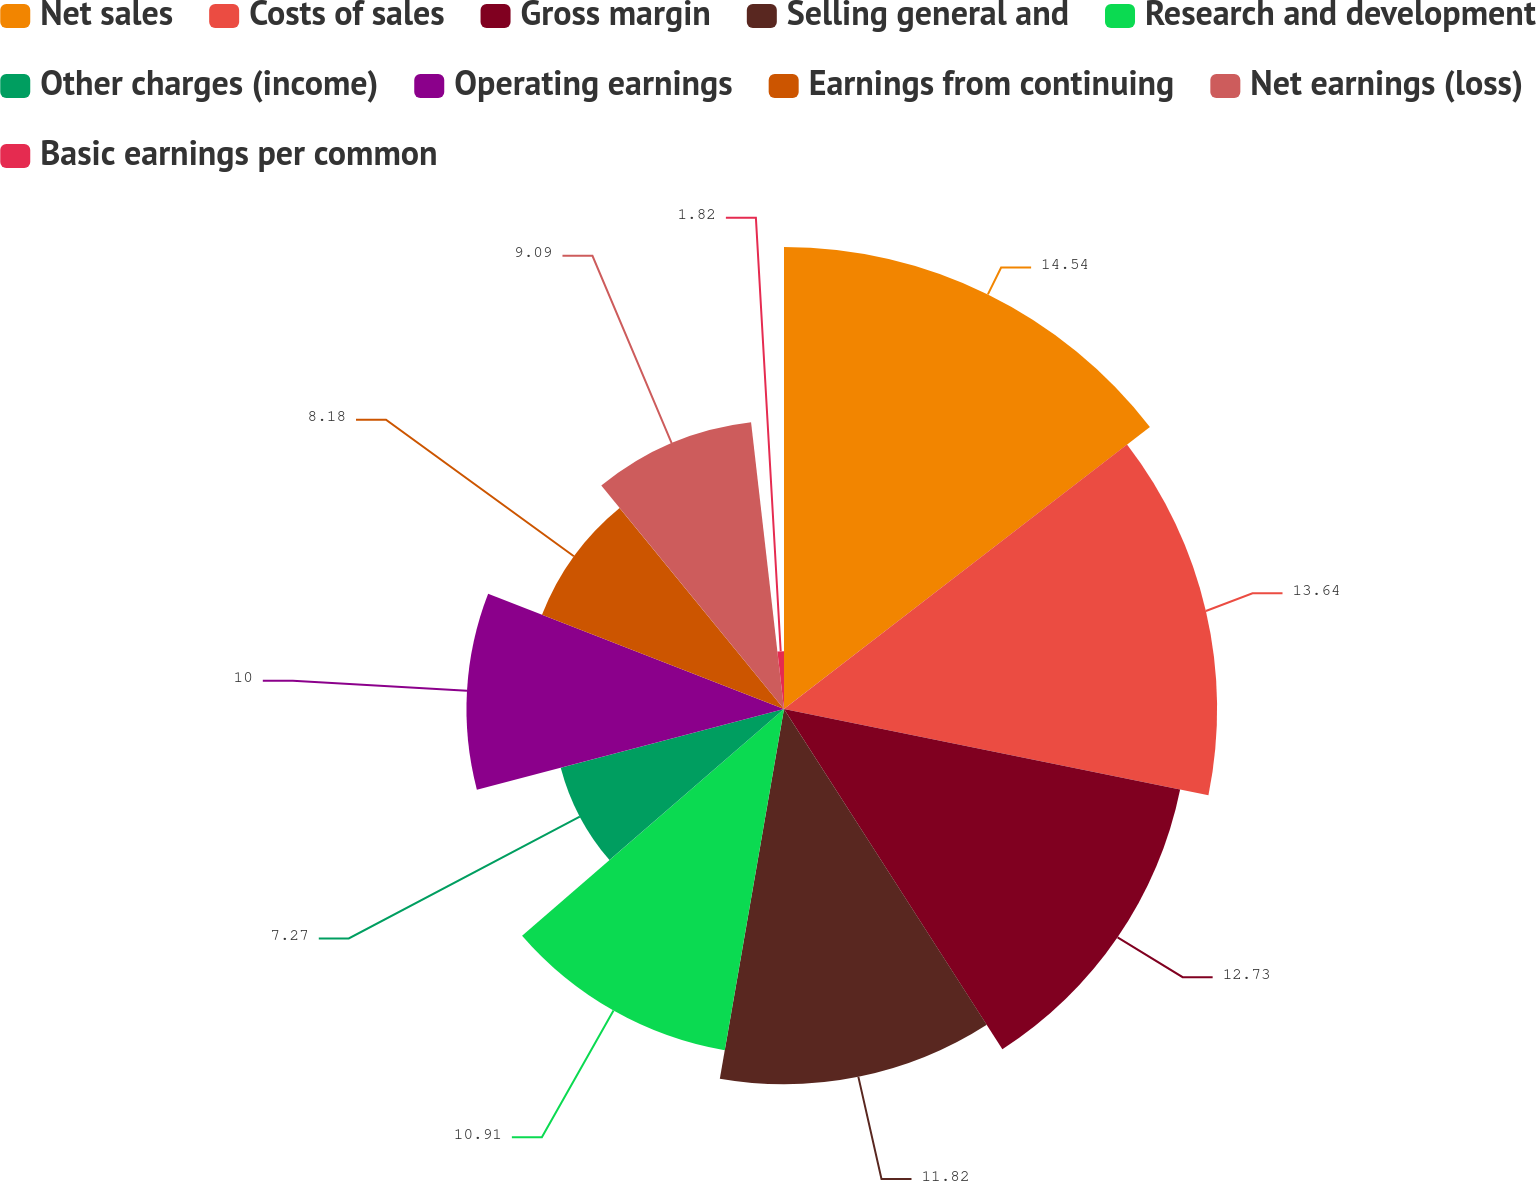Convert chart to OTSL. <chart><loc_0><loc_0><loc_500><loc_500><pie_chart><fcel>Net sales<fcel>Costs of sales<fcel>Gross margin<fcel>Selling general and<fcel>Research and development<fcel>Other charges (income)<fcel>Operating earnings<fcel>Earnings from continuing<fcel>Net earnings (loss)<fcel>Basic earnings per common<nl><fcel>14.55%<fcel>13.64%<fcel>12.73%<fcel>11.82%<fcel>10.91%<fcel>7.27%<fcel>10.0%<fcel>8.18%<fcel>9.09%<fcel>1.82%<nl></chart> 